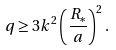Convert formula to latex. <formula><loc_0><loc_0><loc_500><loc_500>q \geq 3 k ^ { 2 } \left ( \frac { R _ { * } } { a } \right ) ^ { 2 } .</formula> 